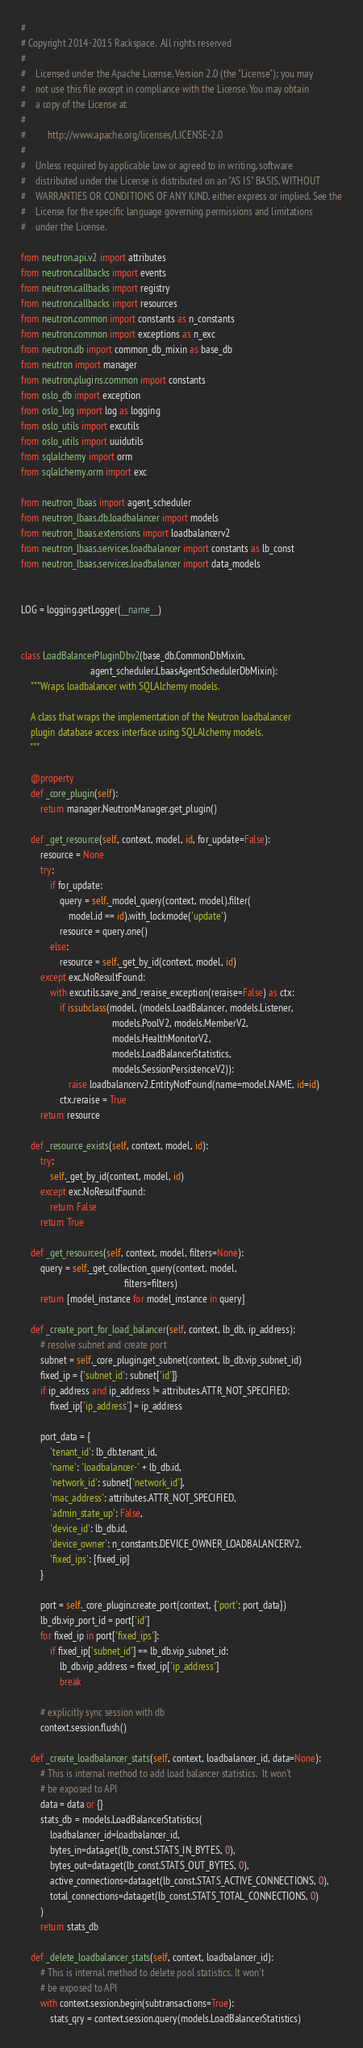<code> <loc_0><loc_0><loc_500><loc_500><_Python_>#
# Copyright 2014-2015 Rackspace.  All rights reserved
#
#    Licensed under the Apache License, Version 2.0 (the "License"); you may
#    not use this file except in compliance with the License. You may obtain
#    a copy of the License at
#
#         http://www.apache.org/licenses/LICENSE-2.0
#
#    Unless required by applicable law or agreed to in writing, software
#    distributed under the License is distributed on an "AS IS" BASIS, WITHOUT
#    WARRANTIES OR CONDITIONS OF ANY KIND, either express or implied. See the
#    License for the specific language governing permissions and limitations
#    under the License.

from neutron.api.v2 import attributes
from neutron.callbacks import events
from neutron.callbacks import registry
from neutron.callbacks import resources
from neutron.common import constants as n_constants
from neutron.common import exceptions as n_exc
from neutron.db import common_db_mixin as base_db
from neutron import manager
from neutron.plugins.common import constants
from oslo_db import exception
from oslo_log import log as logging
from oslo_utils import excutils
from oslo_utils import uuidutils
from sqlalchemy import orm
from sqlalchemy.orm import exc

from neutron_lbaas import agent_scheduler
from neutron_lbaas.db.loadbalancer import models
from neutron_lbaas.extensions import loadbalancerv2
from neutron_lbaas.services.loadbalancer import constants as lb_const
from neutron_lbaas.services.loadbalancer import data_models


LOG = logging.getLogger(__name__)


class LoadBalancerPluginDbv2(base_db.CommonDbMixin,
                             agent_scheduler.LbaasAgentSchedulerDbMixin):
    """Wraps loadbalancer with SQLAlchemy models.

    A class that wraps the implementation of the Neutron loadbalancer
    plugin database access interface using SQLAlchemy models.
    """

    @property
    def _core_plugin(self):
        return manager.NeutronManager.get_plugin()

    def _get_resource(self, context, model, id, for_update=False):
        resource = None
        try:
            if for_update:
                query = self._model_query(context, model).filter(
                    model.id == id).with_lockmode('update')
                resource = query.one()
            else:
                resource = self._get_by_id(context, model, id)
        except exc.NoResultFound:
            with excutils.save_and_reraise_exception(reraise=False) as ctx:
                if issubclass(model, (models.LoadBalancer, models.Listener,
                                      models.PoolV2, models.MemberV2,
                                      models.HealthMonitorV2,
                                      models.LoadBalancerStatistics,
                                      models.SessionPersistenceV2)):
                    raise loadbalancerv2.EntityNotFound(name=model.NAME, id=id)
                ctx.reraise = True
        return resource

    def _resource_exists(self, context, model, id):
        try:
            self._get_by_id(context, model, id)
        except exc.NoResultFound:
            return False
        return True

    def _get_resources(self, context, model, filters=None):
        query = self._get_collection_query(context, model,
                                           filters=filters)
        return [model_instance for model_instance in query]

    def _create_port_for_load_balancer(self, context, lb_db, ip_address):
        # resolve subnet and create port
        subnet = self._core_plugin.get_subnet(context, lb_db.vip_subnet_id)
        fixed_ip = {'subnet_id': subnet['id']}
        if ip_address and ip_address != attributes.ATTR_NOT_SPECIFIED:
            fixed_ip['ip_address'] = ip_address

        port_data = {
            'tenant_id': lb_db.tenant_id,
            'name': 'loadbalancer-' + lb_db.id,
            'network_id': subnet['network_id'],
            'mac_address': attributes.ATTR_NOT_SPECIFIED,
            'admin_state_up': False,
            'device_id': lb_db.id,
            'device_owner': n_constants.DEVICE_OWNER_LOADBALANCERV2,
            'fixed_ips': [fixed_ip]
        }

        port = self._core_plugin.create_port(context, {'port': port_data})
        lb_db.vip_port_id = port['id']
        for fixed_ip in port['fixed_ips']:
            if fixed_ip['subnet_id'] == lb_db.vip_subnet_id:
                lb_db.vip_address = fixed_ip['ip_address']
                break

        # explicitly sync session with db
        context.session.flush()

    def _create_loadbalancer_stats(self, context, loadbalancer_id, data=None):
        # This is internal method to add load balancer statistics.  It won't
        # be exposed to API
        data = data or {}
        stats_db = models.LoadBalancerStatistics(
            loadbalancer_id=loadbalancer_id,
            bytes_in=data.get(lb_const.STATS_IN_BYTES, 0),
            bytes_out=data.get(lb_const.STATS_OUT_BYTES, 0),
            active_connections=data.get(lb_const.STATS_ACTIVE_CONNECTIONS, 0),
            total_connections=data.get(lb_const.STATS_TOTAL_CONNECTIONS, 0)
        )
        return stats_db

    def _delete_loadbalancer_stats(self, context, loadbalancer_id):
        # This is internal method to delete pool statistics. It won't
        # be exposed to API
        with context.session.begin(subtransactions=True):
            stats_qry = context.session.query(models.LoadBalancerStatistics)</code> 